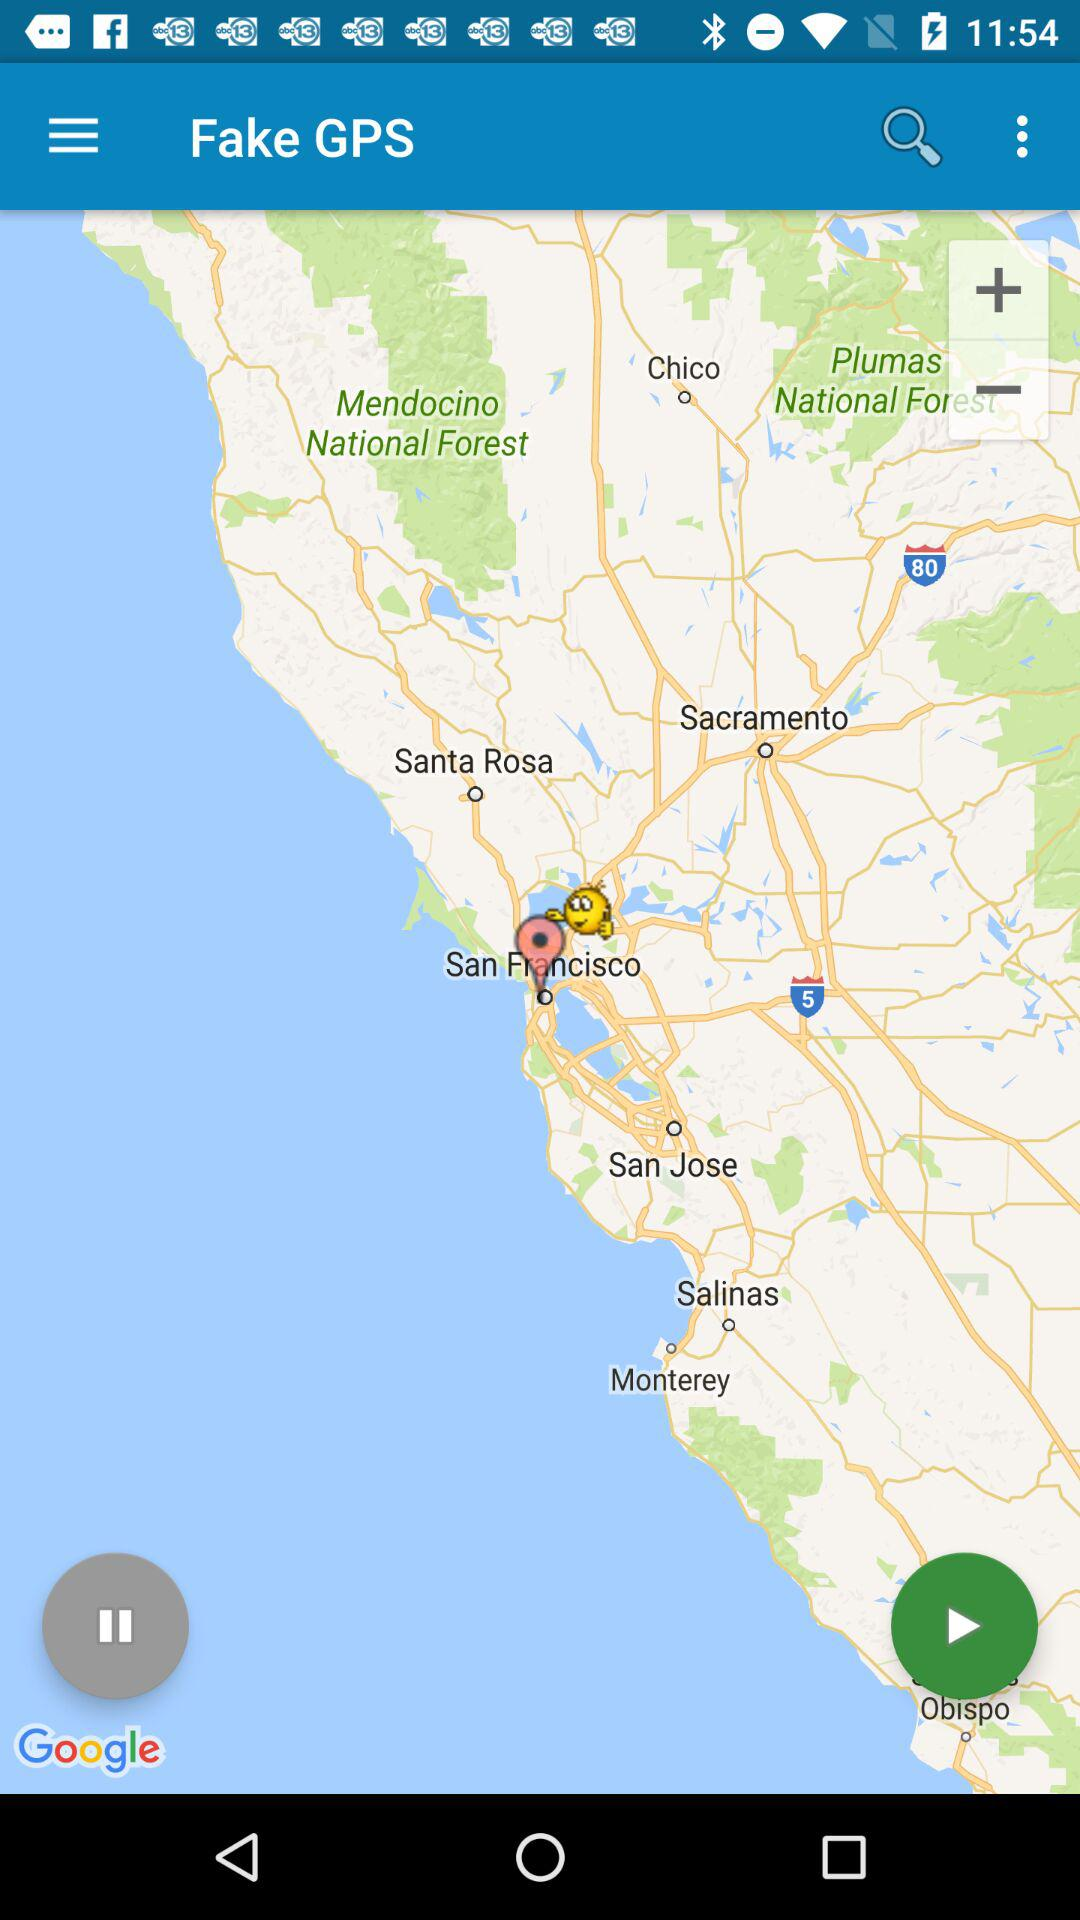What is the name of the application? The name of the application is "Fake GPS". 